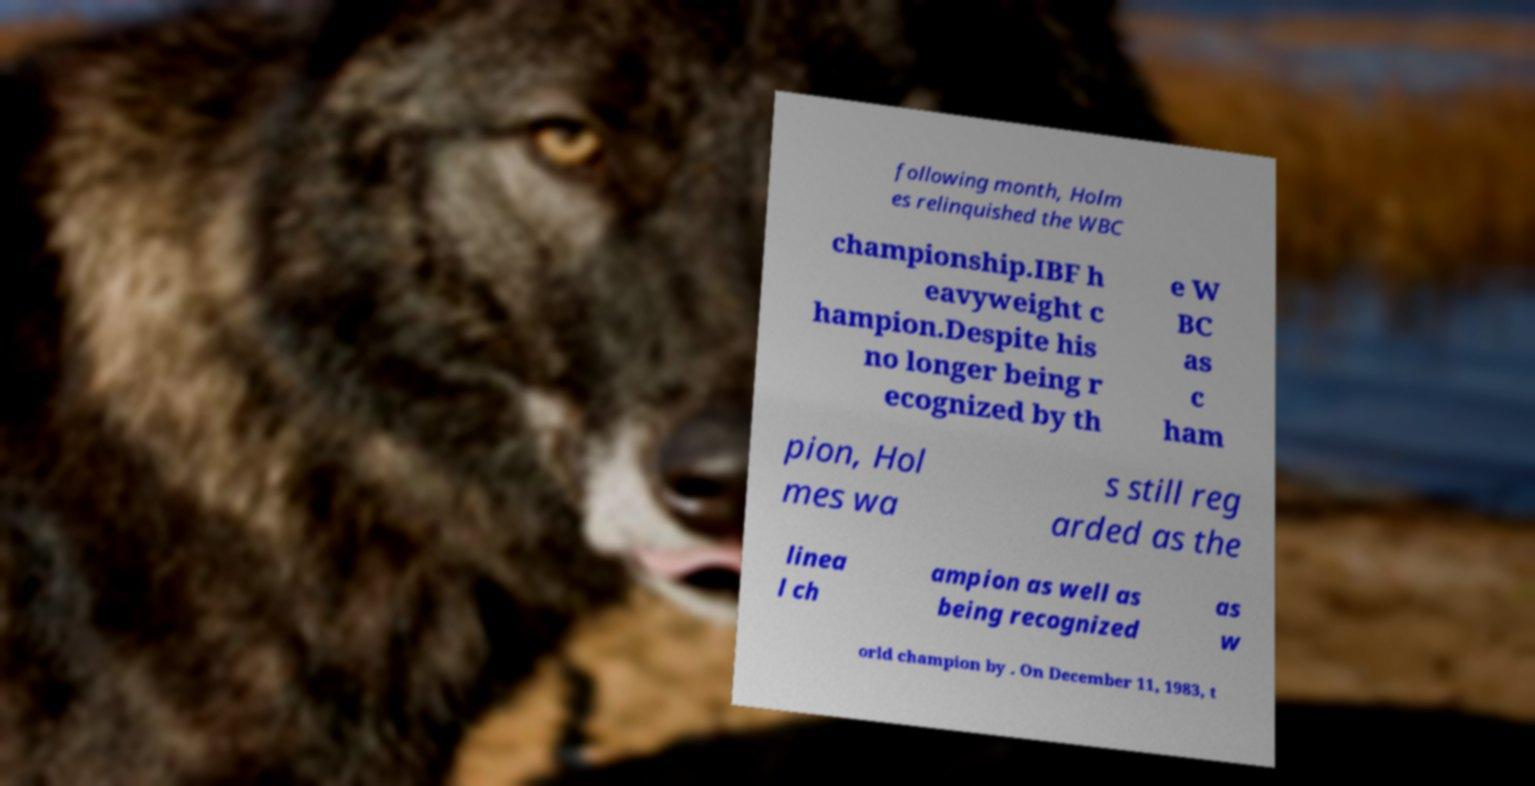There's text embedded in this image that I need extracted. Can you transcribe it verbatim? following month, Holm es relinquished the WBC championship.IBF h eavyweight c hampion.Despite his no longer being r ecognized by th e W BC as c ham pion, Hol mes wa s still reg arded as the linea l ch ampion as well as being recognized as w orld champion by . On December 11, 1983, t 